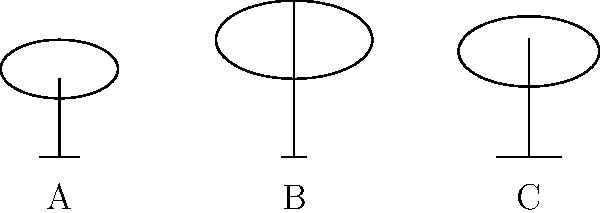In the context of television broadcasting in Hong Kong, three different antenna designs (A, B, and C) are shown above with their respective radiation patterns. Which antenna design would be most effective for receiving signals from a TV transmitter located directly above the antenna, and why? To determine the most effective antenna for receiving signals from a transmitter directly above, we need to analyze the radiation patterns:

1. Radiation pattern analysis:
   - Antenna A: Relatively uniform pattern with moderate upward reception.
   - Antenna B: Elongated pattern with strong upward reception.
   - Antenna C: Wide pattern with good upward and lateral reception.

2. Signal reception principle:
   The strength of signal reception is proportional to the intensity of the radiation pattern in the direction of the transmitter.

3. Transmitter location:
   The question states that the transmitter is directly above the antenna.

4. Comparing upward reception:
   - Antenna B has the strongest and most focused upward radiation pattern.
   - Antennas A and C have weaker upward patterns compared to B.

5. Efficiency consideration:
   Antenna B's design focuses more energy upward, making it more efficient for receiving signals from directly above.

6. Hong Kong context:
   Given the city's dense urban environment and hilly terrain, a focused upward pattern like Antenna B's can help minimize interference from reflections and maximize direct signal reception from hilltop transmitters.

Therefore, Antenna B would be the most effective for receiving signals from a TV transmitter located directly above.
Answer: Antenna B 